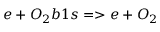Convert formula to latex. <formula><loc_0><loc_0><loc_500><loc_500>e + O _ { 2 } b 1 s = > e + O _ { 2 }</formula> 